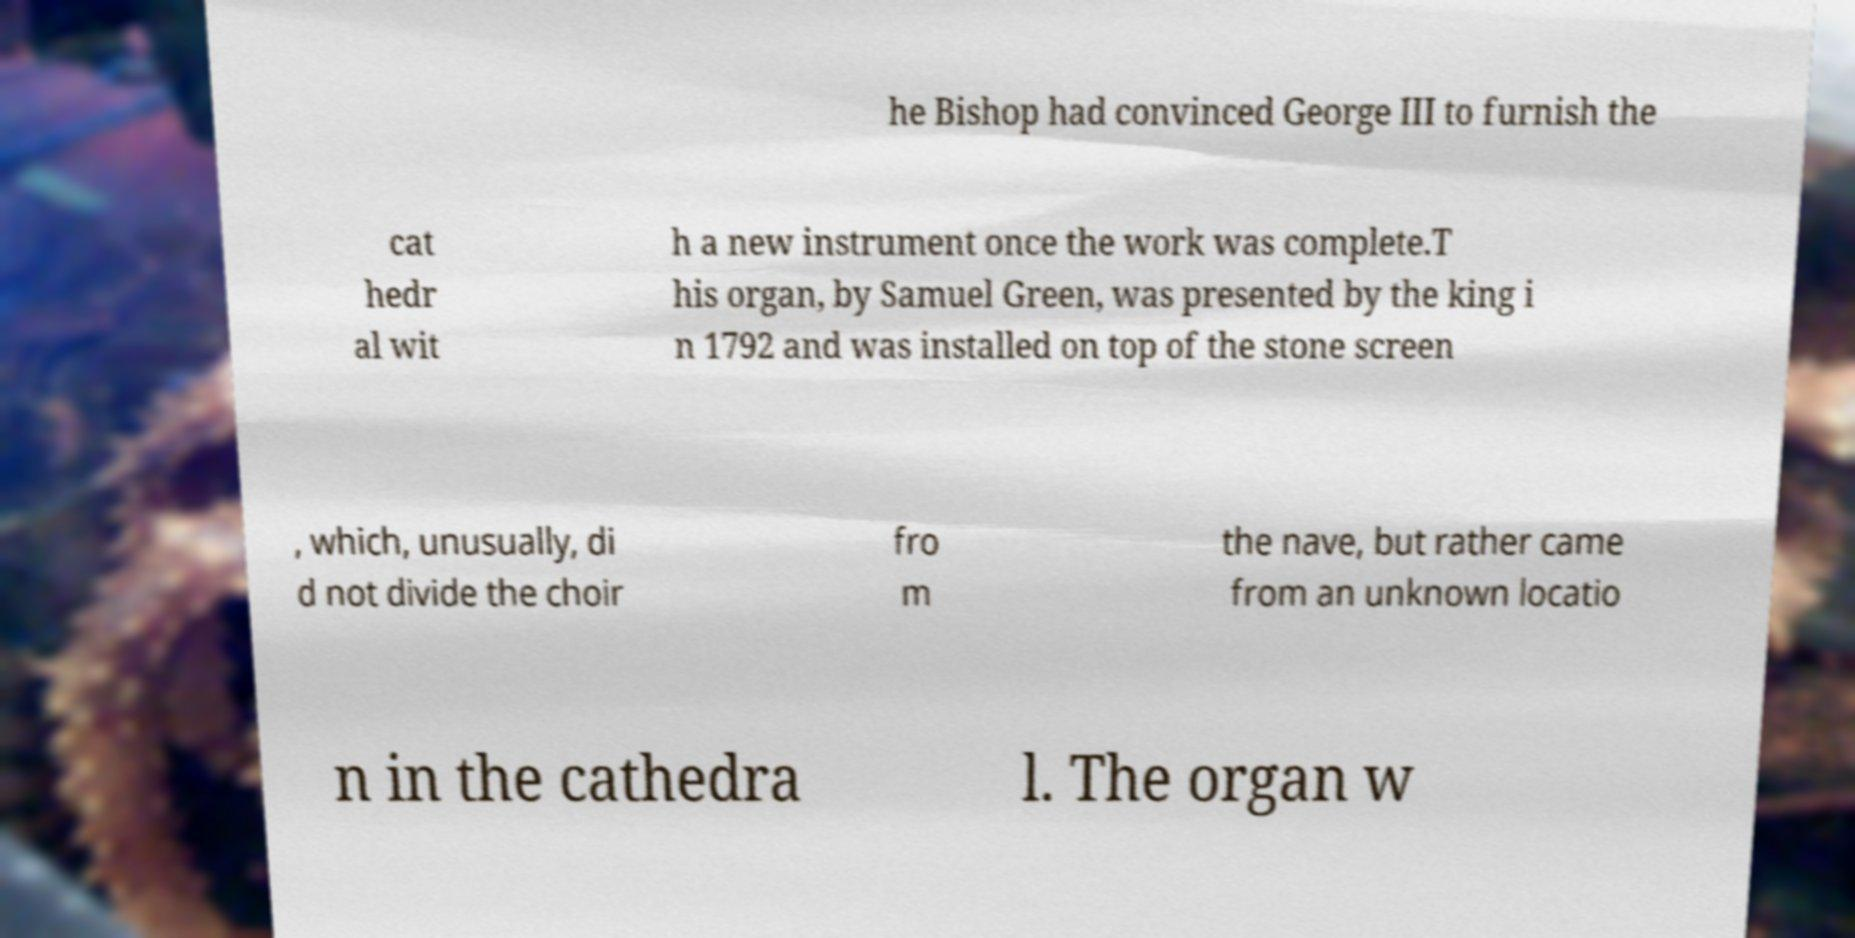Can you read and provide the text displayed in the image?This photo seems to have some interesting text. Can you extract and type it out for me? he Bishop had convinced George III to furnish the cat hedr al wit h a new instrument once the work was complete.T his organ, by Samuel Green, was presented by the king i n 1792 and was installed on top of the stone screen , which, unusually, di d not divide the choir fro m the nave, but rather came from an unknown locatio n in the cathedra l. The organ w 